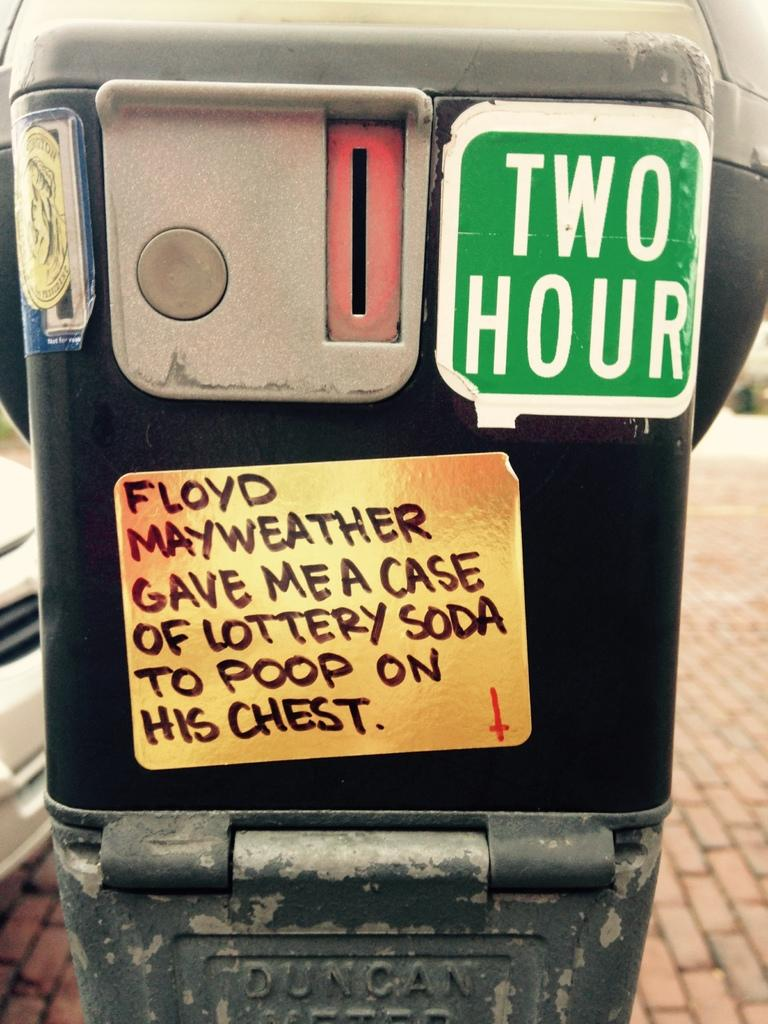Provide a one-sentence caption for the provided image. A two hour parking meter on which someone has placed a sticker stating "Floyd Mayweather gave me a case of lottery soda to poop on his chest". 